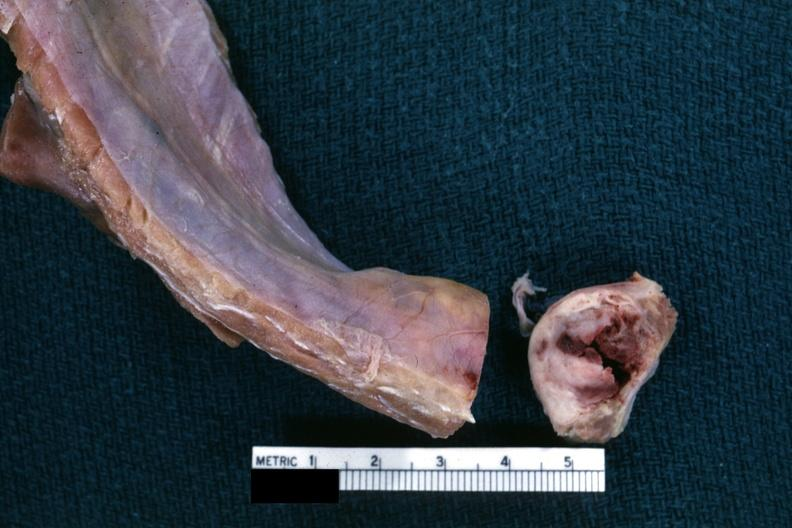what is present?
Answer the question using a single word or phrase. Joints 